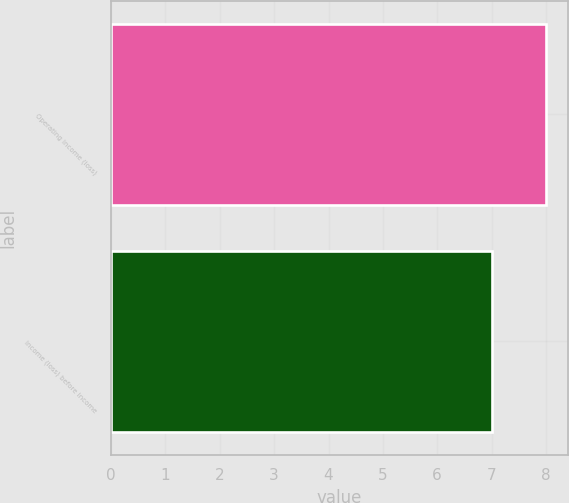Convert chart to OTSL. <chart><loc_0><loc_0><loc_500><loc_500><bar_chart><fcel>Operating income (loss)<fcel>Income (loss) before income<nl><fcel>8<fcel>7<nl></chart> 